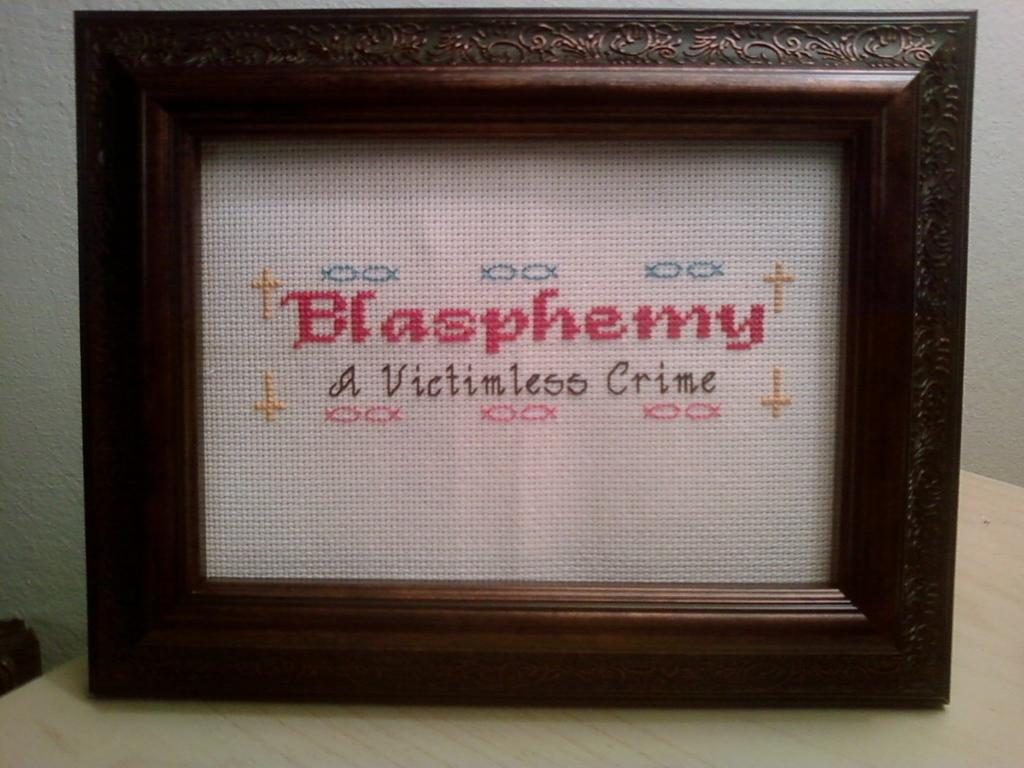<image>
Provide a brief description of the given image. A framed needlepoint reading Blasphemy a victimless crime. 